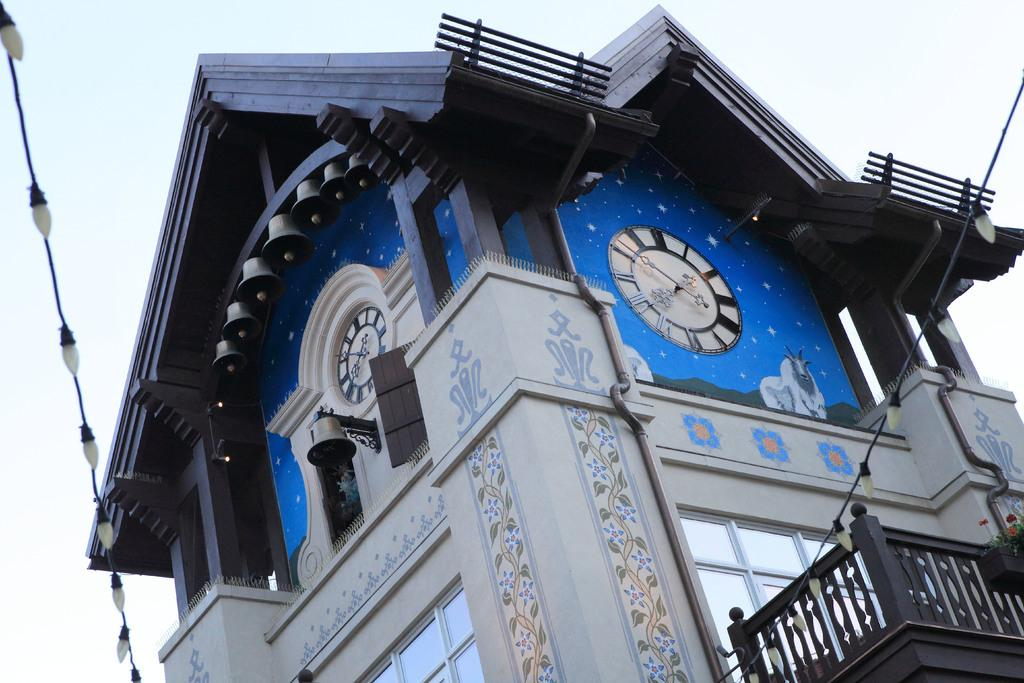What is the main structure in the middle of the image? There is a building in the middle of the image. How many clocks can be seen in the image? There are two clocks in the image. What type of barrier is present in the image? There is a fence in the image. Can you describe the lighting in the image? There is a light in the image. What type of electrical infrastructure is visible in the image? There is a cable wire in the image. What is the color of the sky in the image? The sky is white in the image. Can you see a kite flying in the white sky of the image? There is no kite visible in the image; only the building, clocks, fence, light, cable wire, and the white sky are present. 